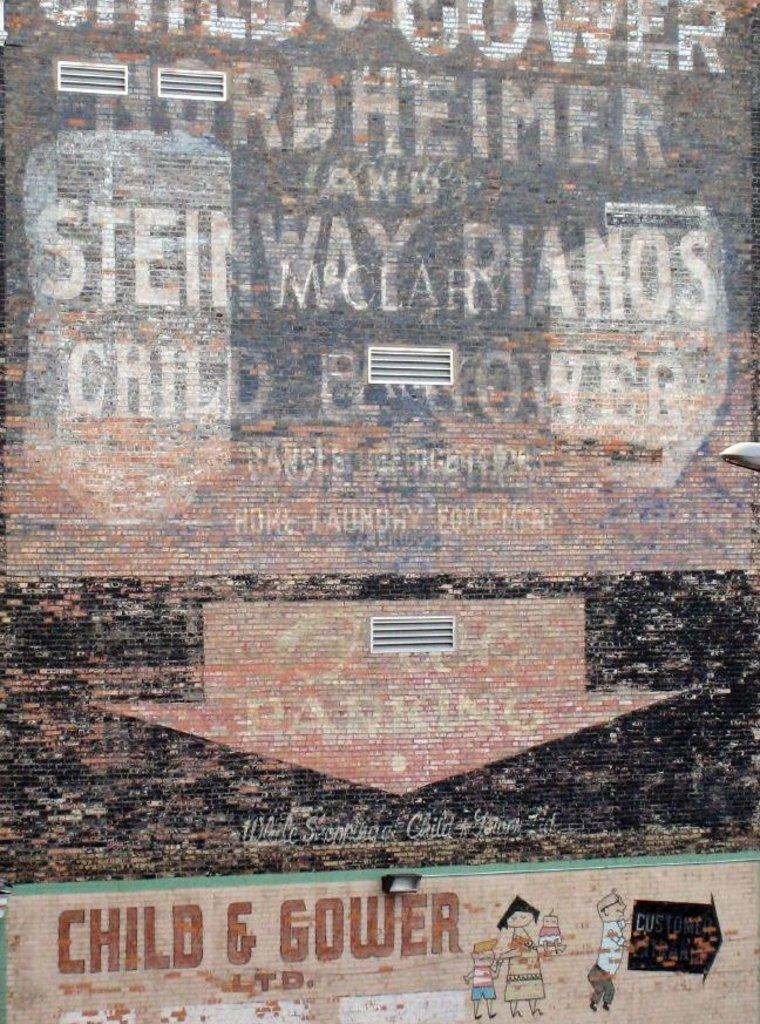What is the company name?
Provide a short and direct response. Unanswerable. What kind of equipment do they have?
Provide a short and direct response. Pianos. 